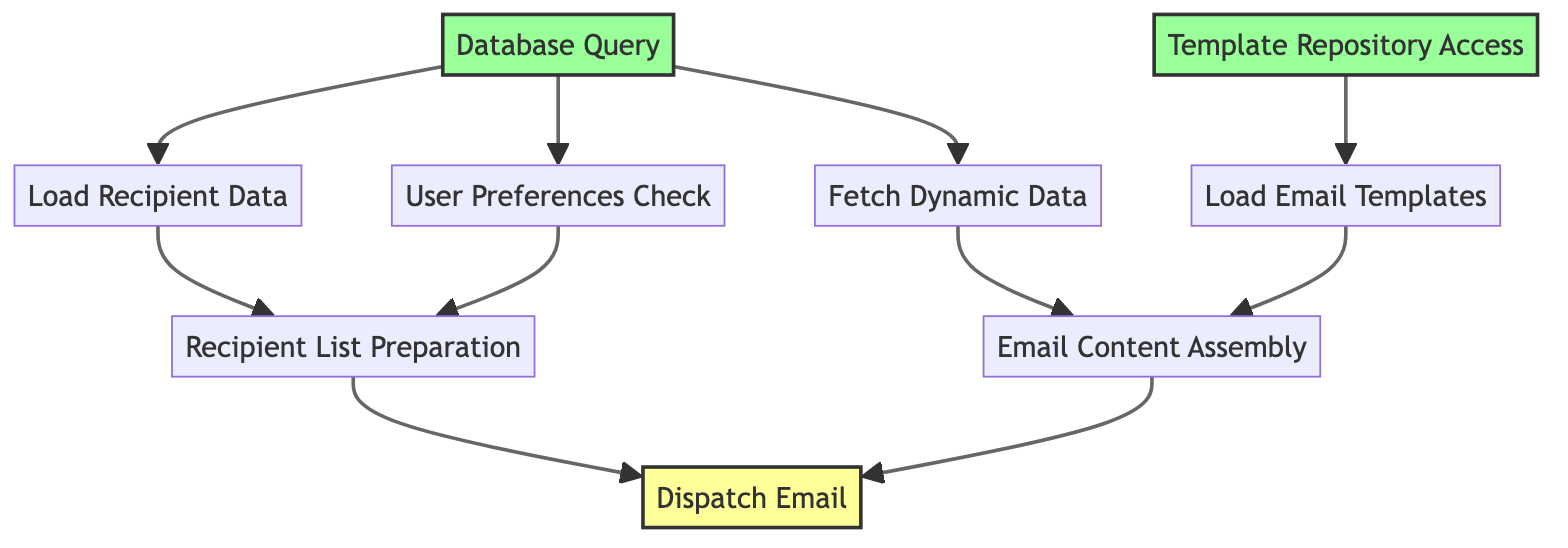What is the final step in the email notification process? The final step in the process is labeled as "Dispatch Email," which indicates where the email is sent out to recipients.
Answer: Dispatch Email How many steps are there in the automated email notification flow? Counting all the nodes from bottom to top, there are eight steps involved in the flow: Database Query, Template Repository Access, Load Recipient Data, User Preferences Check, Load Email Templates, Fetch Dynamic Data, Recipient List Preparation, Email Content Assembly, and Dispatch Email.
Answer: Eight Which step depends on the "Load Recipient Data"? The "Recipient List Preparation" step directly depends on "Load Recipient Data" as indicated by the arrow connecting them.
Answer: Recipient List Preparation What do "Fetch Dynamic Data" and "Load Email Templates" lead to? Both "Fetch Dynamic Data" and "Load Email Templates" lead to the "Email Content Assembly" step, as their outputs are required to assemble the email.
Answer: Email Content Assembly Which component checks user preferences to ensure recipients receive the email? The component that checks user preferences to ensure recipients are included appropriately is "User Preferences Check."
Answer: User Preferences Check What initiates the email content assembly process? The email content assembly process is initiated by two components: "Fetch Dynamic Data" and "Load Email Templates," both of which are prerequisites for "Email Content Assembly."
Answer: Fetch Dynamic Data, Load Email Templates What is the main purpose of the "Database Query" step? The purpose of the "Database Query" step is to execute a query to fetch necessary data from the backend database required for different processes within the flow.
Answer: Fetch necessary data How many components lead to the "Dispatch Email" step? There are three components leading to the "Dispatch Email" step, which are "Recipient List Preparation," "Email Content Assembly," and "Email Content Assembly."
Answer: Three Which two steps provide input to "Recipient List Preparation"? The two steps providing input to "Recipient List Preparation" are "Load Recipient Data" and "User Preferences Check," as both are required for compiling the recipient list.
Answer: Load Recipient Data, User Preferences Check What type of access is needed to load email templates? "Template Repository Access" is necessary to load the email templates, which informs the "Load Email Templates" step.
Answer: Template Repository Access 